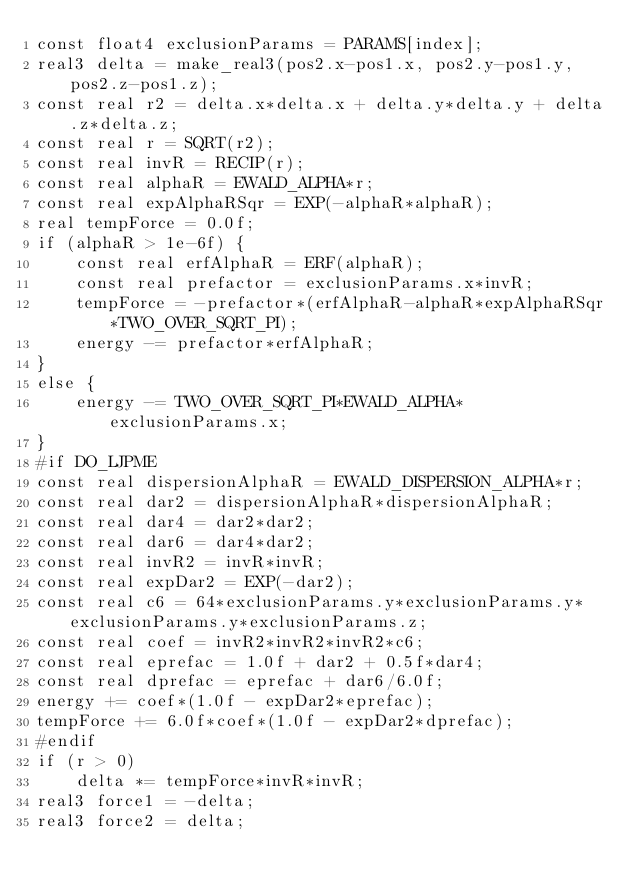<code> <loc_0><loc_0><loc_500><loc_500><_Cuda_>const float4 exclusionParams = PARAMS[index];
real3 delta = make_real3(pos2.x-pos1.x, pos2.y-pos1.y, pos2.z-pos1.z);
const real r2 = delta.x*delta.x + delta.y*delta.y + delta.z*delta.z;
const real r = SQRT(r2);
const real invR = RECIP(r);
const real alphaR = EWALD_ALPHA*r;
const real expAlphaRSqr = EXP(-alphaR*alphaR);
real tempForce = 0.0f;
if (alphaR > 1e-6f) {
    const real erfAlphaR = ERF(alphaR);
    const real prefactor = exclusionParams.x*invR;
    tempForce = -prefactor*(erfAlphaR-alphaR*expAlphaRSqr*TWO_OVER_SQRT_PI);
    energy -= prefactor*erfAlphaR;
}
else {
    energy -= TWO_OVER_SQRT_PI*EWALD_ALPHA*exclusionParams.x;
}
#if DO_LJPME
const real dispersionAlphaR = EWALD_DISPERSION_ALPHA*r;
const real dar2 = dispersionAlphaR*dispersionAlphaR;
const real dar4 = dar2*dar2;
const real dar6 = dar4*dar2;
const real invR2 = invR*invR;
const real expDar2 = EXP(-dar2);
const real c6 = 64*exclusionParams.y*exclusionParams.y*exclusionParams.y*exclusionParams.z;
const real coef = invR2*invR2*invR2*c6;
const real eprefac = 1.0f + dar2 + 0.5f*dar4;
const real dprefac = eprefac + dar6/6.0f;
energy += coef*(1.0f - expDar2*eprefac);
tempForce += 6.0f*coef*(1.0f - expDar2*dprefac);
#endif
if (r > 0)
    delta *= tempForce*invR*invR;
real3 force1 = -delta;
real3 force2 = delta;
</code> 